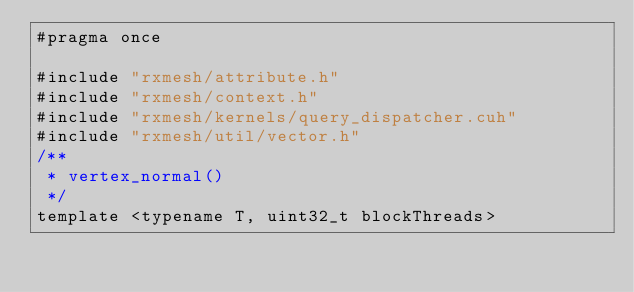Convert code to text. <code><loc_0><loc_0><loc_500><loc_500><_Cuda_>#pragma once

#include "rxmesh/attribute.h"
#include "rxmesh/context.h"
#include "rxmesh/kernels/query_dispatcher.cuh"
#include "rxmesh/util/vector.h"
/**
 * vertex_normal()
 */
template <typename T, uint32_t blockThreads></code> 